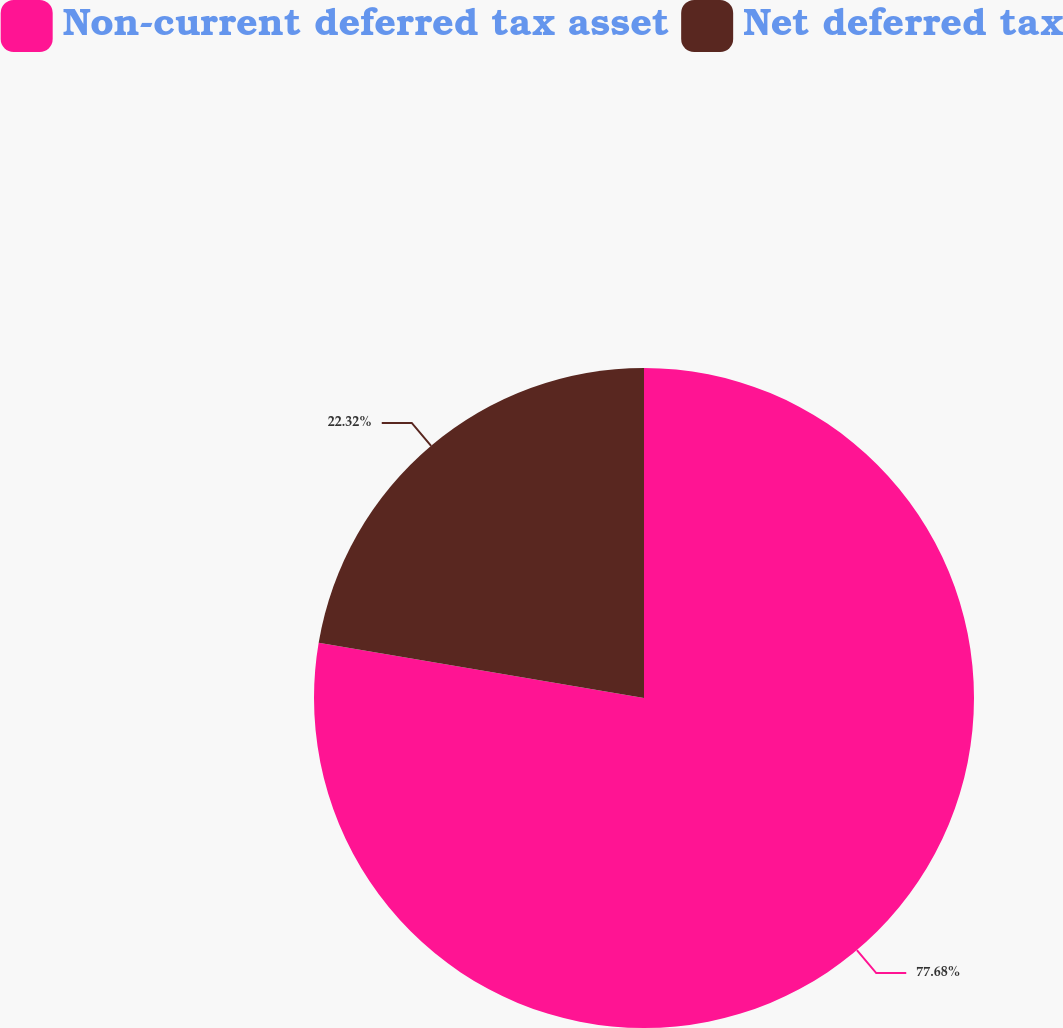<chart> <loc_0><loc_0><loc_500><loc_500><pie_chart><fcel>Non-current deferred tax asset<fcel>Net deferred tax<nl><fcel>77.68%<fcel>22.32%<nl></chart> 